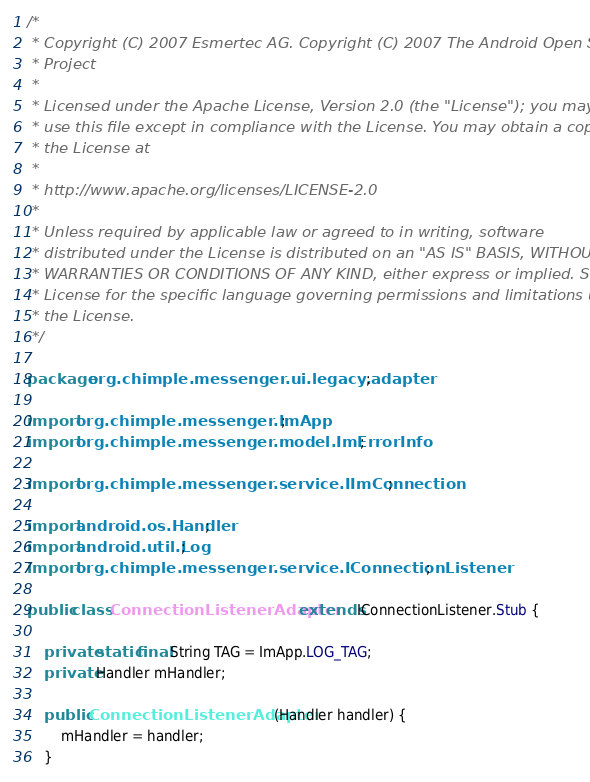Convert code to text. <code><loc_0><loc_0><loc_500><loc_500><_Java_>/*
 * Copyright (C) 2007 Esmertec AG. Copyright (C) 2007 The Android Open Source
 * Project
 *
 * Licensed under the Apache License, Version 2.0 (the "License"); you may not
 * use this file except in compliance with the License. You may obtain a copy of
 * the License at
 *
 * http://www.apache.org/licenses/LICENSE-2.0
 *
 * Unless required by applicable law or agreed to in writing, software
 * distributed under the License is distributed on an "AS IS" BASIS, WITHOUT
 * WARRANTIES OR CONDITIONS OF ANY KIND, either express or implied. See the
 * License for the specific language governing permissions and limitations under
 * the License.
 */

package org.chimple.messenger.ui.legacy.adapter;

import org.chimple.messenger.ImApp;
import org.chimple.messenger.model.ImErrorInfo;

import org.chimple.messenger.service.IImConnection;

import android.os.Handler;
import android.util.Log;
import org.chimple.messenger.service.IConnectionListener;

public class ConnectionListenerAdapter extends IConnectionListener.Stub {

    private static final String TAG = ImApp.LOG_TAG;
    private Handler mHandler;

    public ConnectionListenerAdapter(Handler handler) {
        mHandler = handler;
    }
</code> 